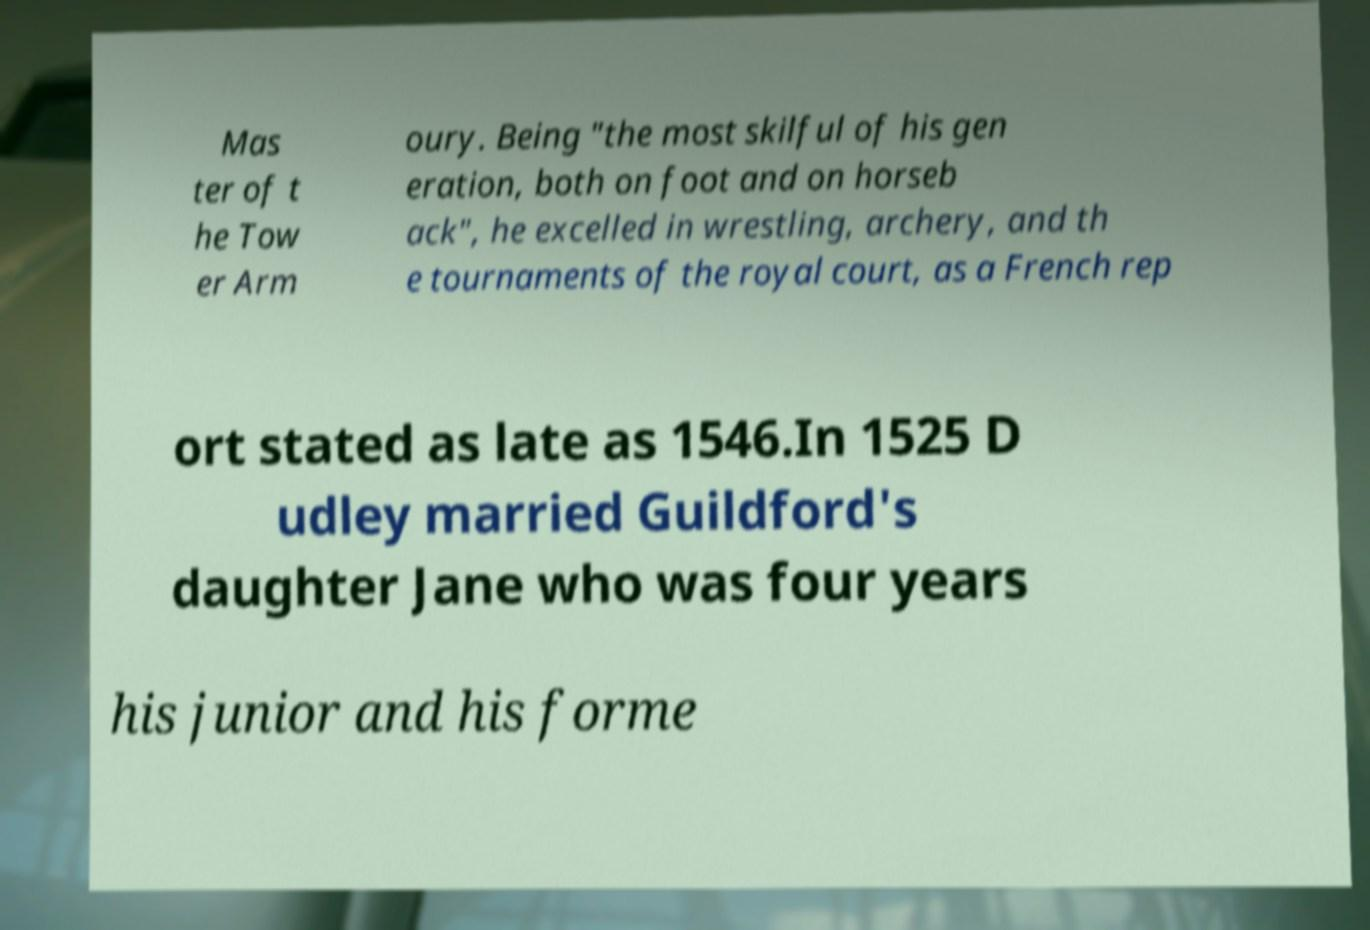There's text embedded in this image that I need extracted. Can you transcribe it verbatim? Mas ter of t he Tow er Arm oury. Being "the most skilful of his gen eration, both on foot and on horseb ack", he excelled in wrestling, archery, and th e tournaments of the royal court, as a French rep ort stated as late as 1546.In 1525 D udley married Guildford's daughter Jane who was four years his junior and his forme 